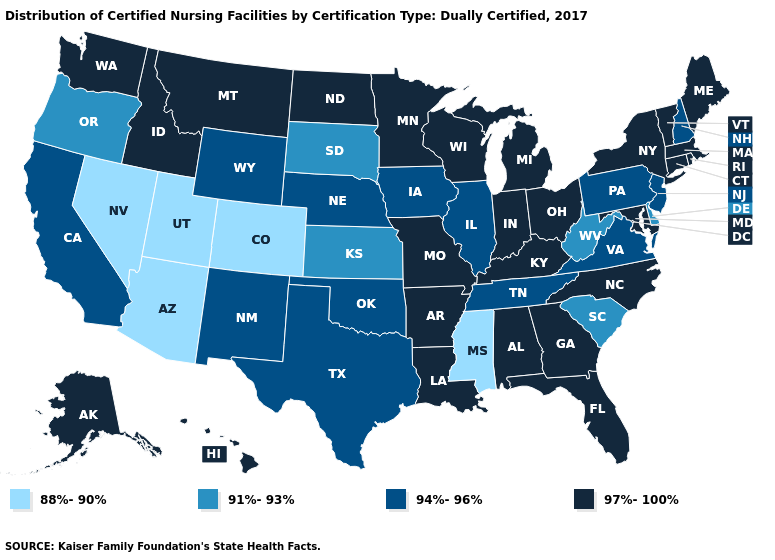What is the lowest value in states that border Georgia?
Answer briefly. 91%-93%. Does North Dakota have the same value as South Carolina?
Concise answer only. No. What is the value of South Dakota?
Short answer required. 91%-93%. Does New Mexico have a higher value than California?
Quick response, please. No. Name the states that have a value in the range 97%-100%?
Write a very short answer. Alabama, Alaska, Arkansas, Connecticut, Florida, Georgia, Hawaii, Idaho, Indiana, Kentucky, Louisiana, Maine, Maryland, Massachusetts, Michigan, Minnesota, Missouri, Montana, New York, North Carolina, North Dakota, Ohio, Rhode Island, Vermont, Washington, Wisconsin. What is the lowest value in the MidWest?
Write a very short answer. 91%-93%. Does the map have missing data?
Give a very brief answer. No. What is the value of Alaska?
Concise answer only. 97%-100%. Name the states that have a value in the range 97%-100%?
Answer briefly. Alabama, Alaska, Arkansas, Connecticut, Florida, Georgia, Hawaii, Idaho, Indiana, Kentucky, Louisiana, Maine, Maryland, Massachusetts, Michigan, Minnesota, Missouri, Montana, New York, North Carolina, North Dakota, Ohio, Rhode Island, Vermont, Washington, Wisconsin. Name the states that have a value in the range 97%-100%?
Quick response, please. Alabama, Alaska, Arkansas, Connecticut, Florida, Georgia, Hawaii, Idaho, Indiana, Kentucky, Louisiana, Maine, Maryland, Massachusetts, Michigan, Minnesota, Missouri, Montana, New York, North Carolina, North Dakota, Ohio, Rhode Island, Vermont, Washington, Wisconsin. What is the highest value in the South ?
Write a very short answer. 97%-100%. Name the states that have a value in the range 88%-90%?
Concise answer only. Arizona, Colorado, Mississippi, Nevada, Utah. Name the states that have a value in the range 94%-96%?
Give a very brief answer. California, Illinois, Iowa, Nebraska, New Hampshire, New Jersey, New Mexico, Oklahoma, Pennsylvania, Tennessee, Texas, Virginia, Wyoming. Name the states that have a value in the range 94%-96%?
Be succinct. California, Illinois, Iowa, Nebraska, New Hampshire, New Jersey, New Mexico, Oklahoma, Pennsylvania, Tennessee, Texas, Virginia, Wyoming. Name the states that have a value in the range 94%-96%?
Be succinct. California, Illinois, Iowa, Nebraska, New Hampshire, New Jersey, New Mexico, Oklahoma, Pennsylvania, Tennessee, Texas, Virginia, Wyoming. 